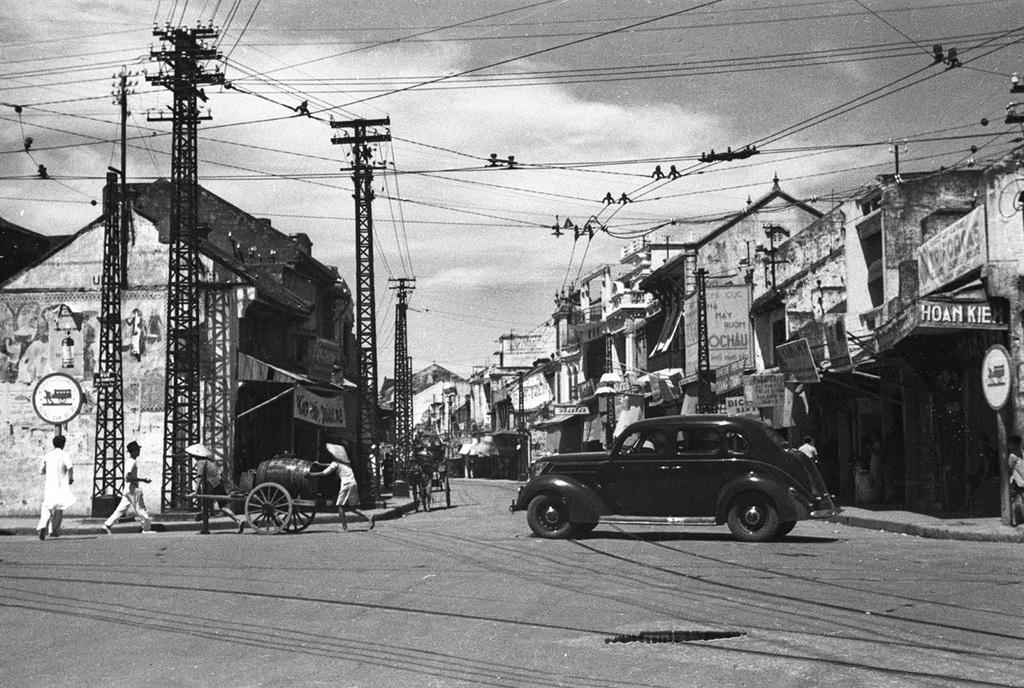What are the people in the image doing? The people in the image are walking. What is the person holding in the image? The person is holding a cart. What type of vehicle can be seen on the road in the image? There is a car on the road in the image. What structures are present with wires in the image? There are towers with wires in the image. What objects are present in the image that might be used for displaying information or advertisements? There are boards in the image. What type of buildings can be seen in the background of the image? Houses are visible in the background of the image. What is visible in the sky in the image? The sky is visible in the background of the image, and clouds are present. What type of meal is being prepared on the cart in the image? There is no meal being prepared on the cart in the image; it is simply being held by a person. What type of berry can be seen growing on the towers in the image? There are no berries present in the image; the towers have wires on them. 